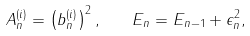<formula> <loc_0><loc_0><loc_500><loc_500>A ^ { ( i ) } _ { n } = \left ( b _ { n } ^ { ( i ) } \right ) ^ { 2 } , \quad E _ { n } = E _ { n - 1 } + \epsilon _ { n } ^ { 2 } ,</formula> 